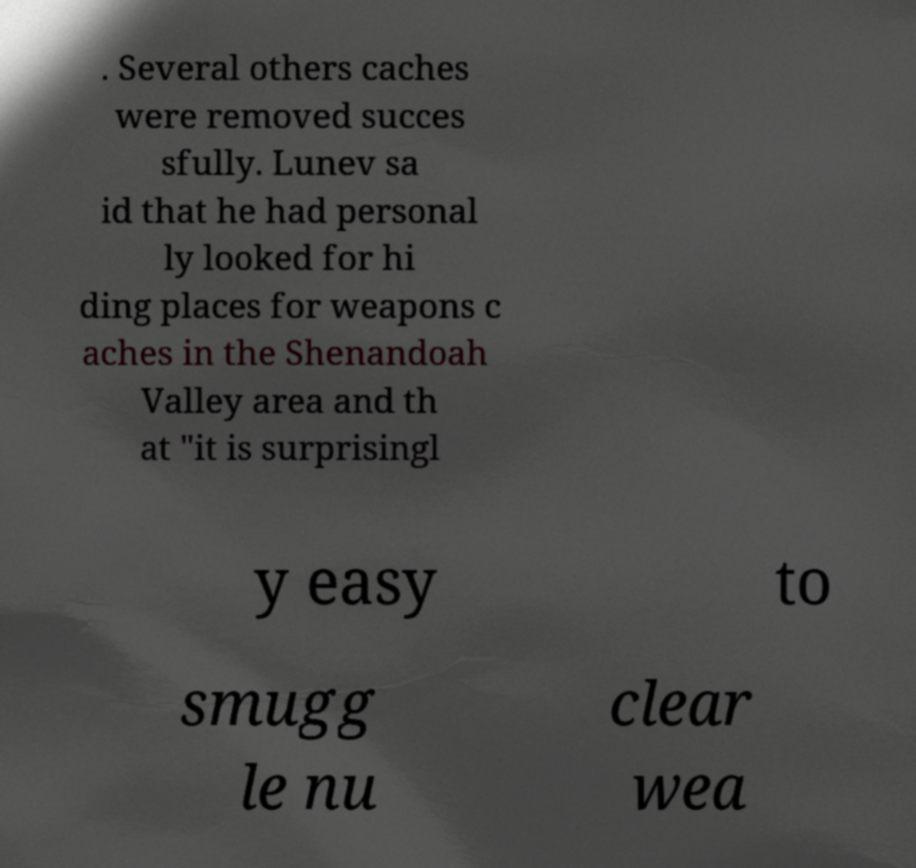For documentation purposes, I need the text within this image transcribed. Could you provide that? . Several others caches were removed succes sfully. Lunev sa id that he had personal ly looked for hi ding places for weapons c aches in the Shenandoah Valley area and th at "it is surprisingl y easy to smugg le nu clear wea 